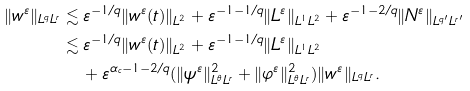Convert formula to latex. <formula><loc_0><loc_0><loc_500><loc_500>\| w ^ { \varepsilon } \| _ { L ^ { q } L ^ { r } } & \lesssim \varepsilon ^ { - 1 / q } \| w ^ { \varepsilon } ( t ) \| _ { L ^ { 2 } } + \varepsilon ^ { - 1 - 1 / q } \| L ^ { \varepsilon } \| _ { L ^ { 1 } L ^ { 2 } } + \varepsilon ^ { - 1 - 2 / q } \| N ^ { \varepsilon } \| _ { L ^ { q ^ { \prime } } L ^ { r ^ { \prime } } } \\ & \lesssim \varepsilon ^ { - 1 / q } \| w ^ { \varepsilon } ( t ) \| _ { L ^ { 2 } } + \varepsilon ^ { - 1 - 1 / q } \| L ^ { \varepsilon } \| _ { L ^ { 1 } L ^ { 2 } } \\ & \quad + \varepsilon ^ { \alpha _ { c } - 1 - 2 / q } ( \| \psi ^ { \varepsilon } \| _ { L ^ { \theta } L ^ { r } } ^ { 2 } + \| \varphi ^ { \varepsilon } \| _ { L ^ { \theta } L ^ { r } } ^ { 2 } ) \| w ^ { \varepsilon } \| _ { L ^ { q } L ^ { r } } .</formula> 